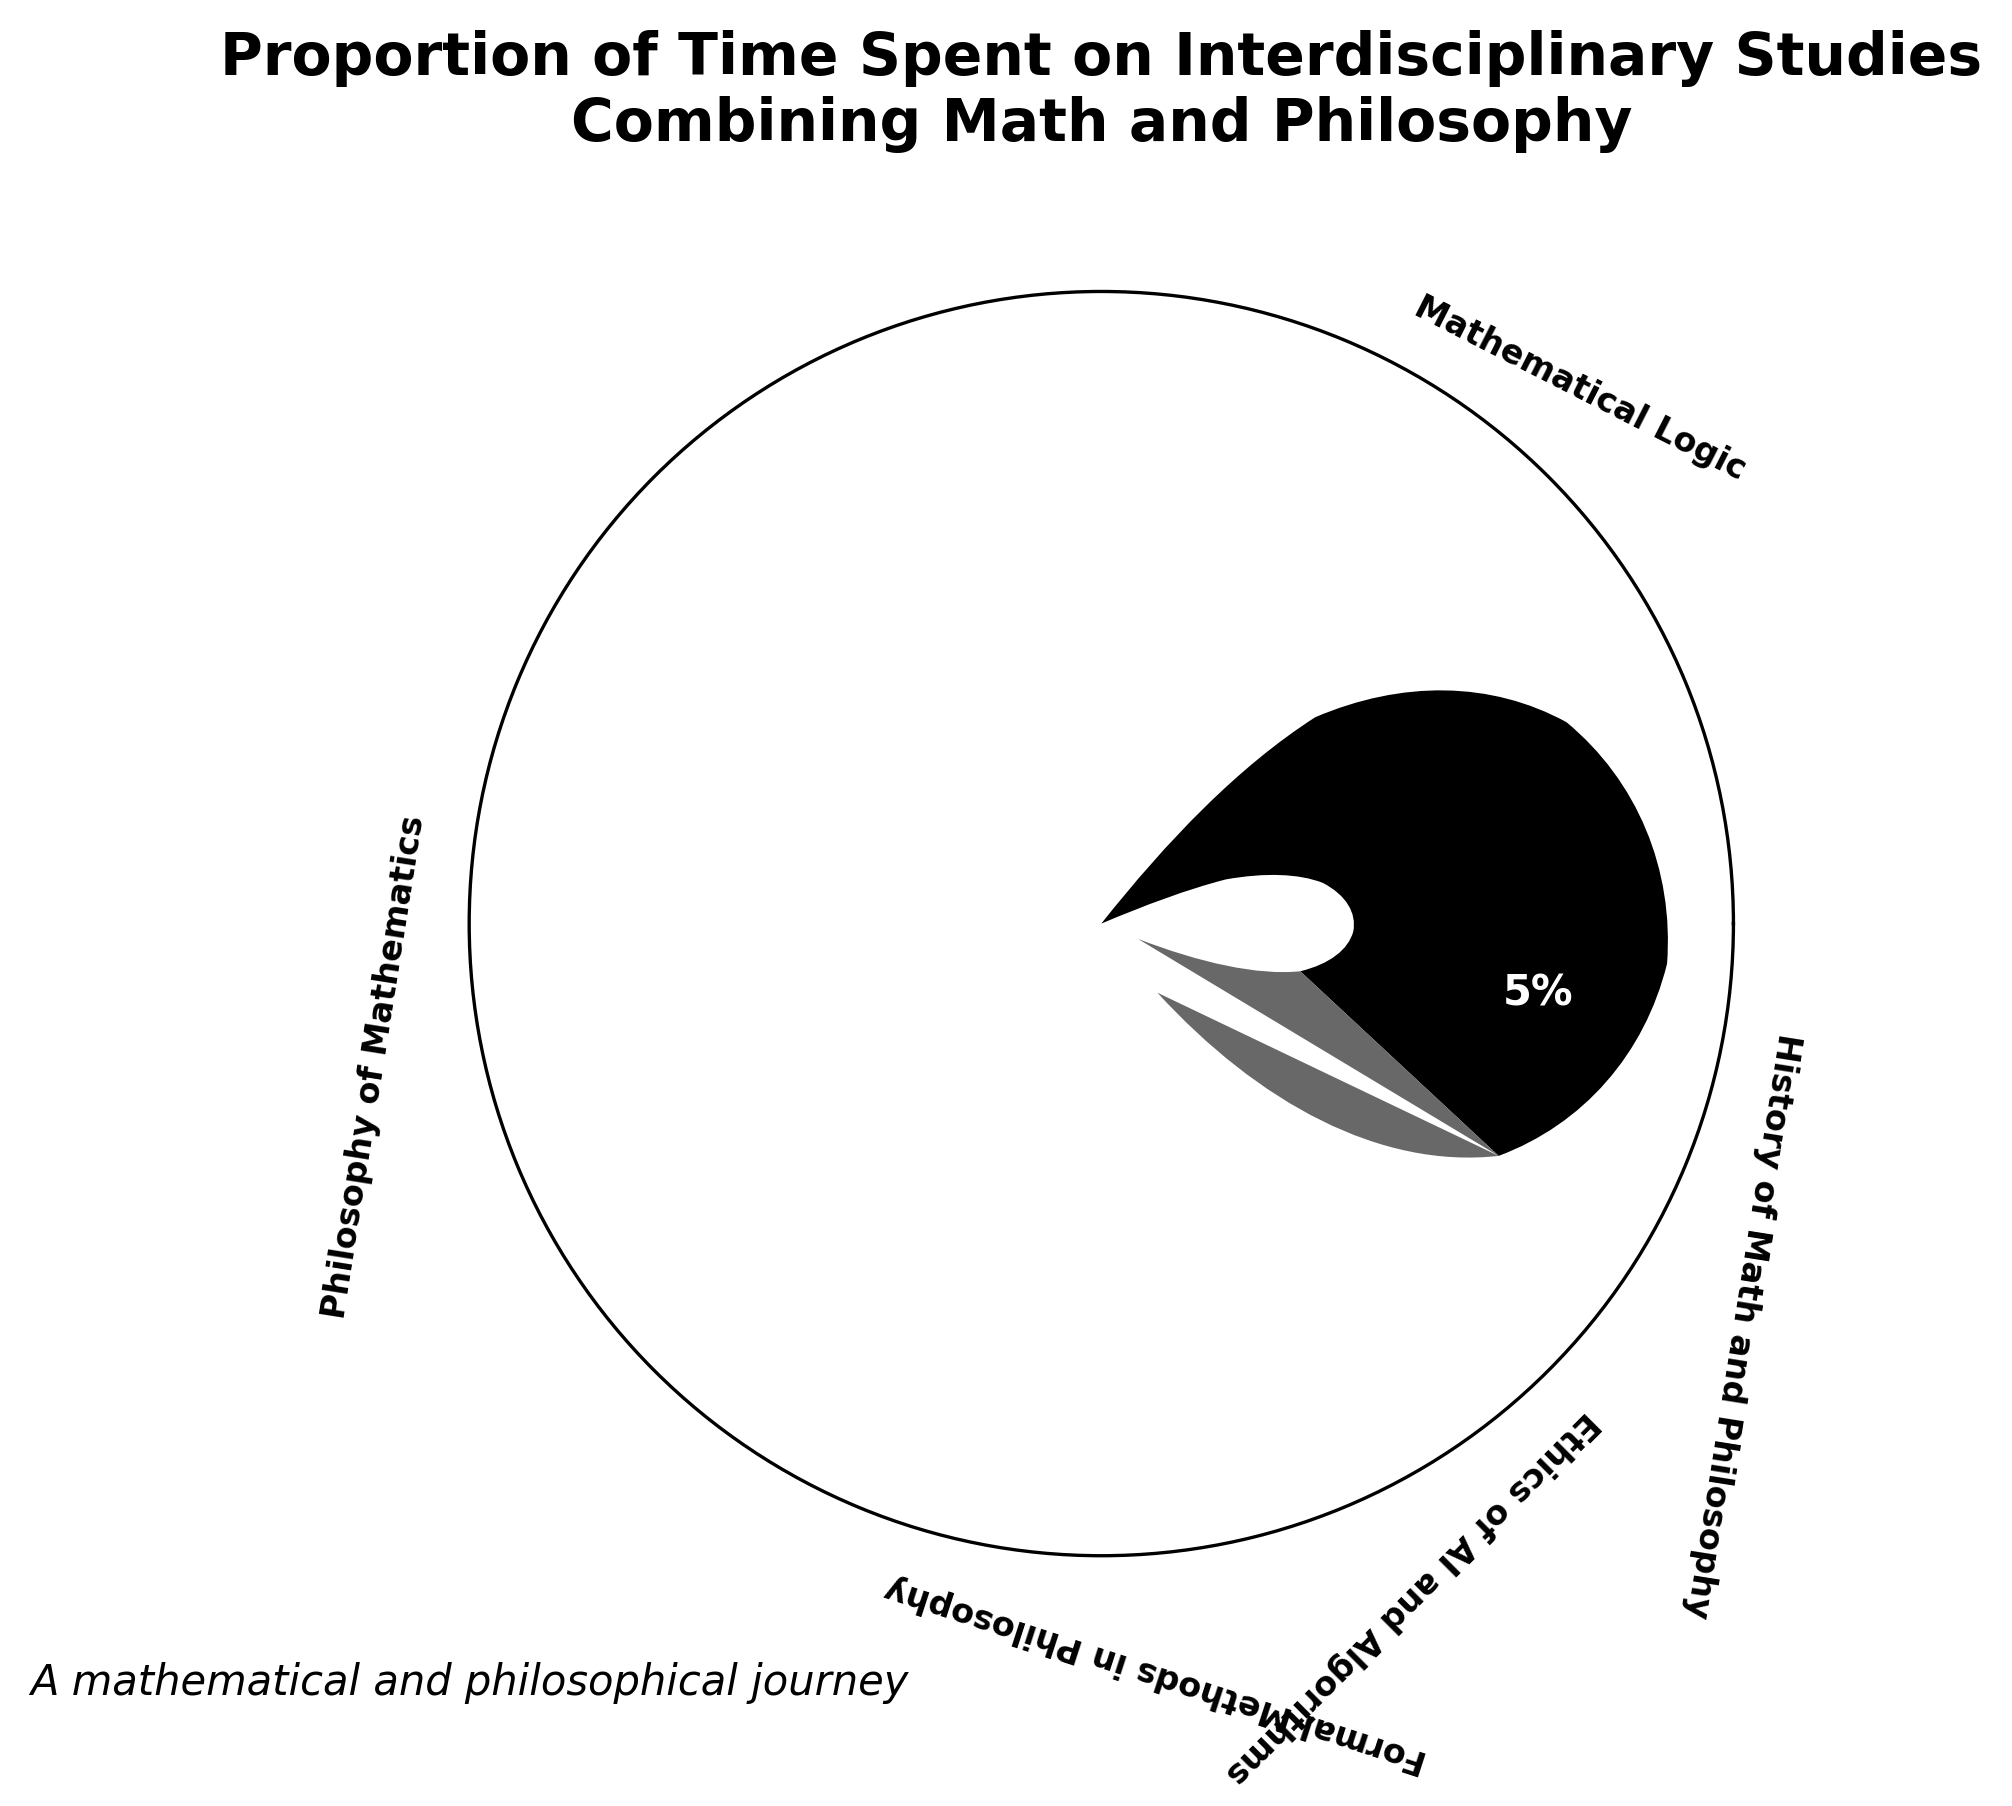what is the title of the plot? The title can be found at the top of the figure. It gives a summary of what the chart is about.
Answer: Proportion of Time Spent on Interdisciplinary Studies Combining Math and Philosophy what category has the highest value? By looking at the wedges and their values, the category with the largest wedge and highest percentage is evident.
Answer: Mathematical Logic how many categories are there in total? The number of distinct segments in the chart represents the number of categories.
Answer: 5 What is the combined proportion for 'Formal Methods in Philosophy' and 'Ethics of AI and Algorithms'? Add the values of the respective categories. Formal Methods in Philosophy: 20% and Ethics of AI and Algorithms: 15%. 20% + 15% = 35%
Answer: 35% Which category has the smallest proportion of time spent? By locating the smallest wedge and observing the percentage, we determine the category.
Answer: History of Math and Philosophy How much more time is spent on 'Mathematical Logic' compared to 'Ethics of AI and Algorithms'? Subtract the percentage of 'Ethics of AI and Algorithms' from 'Mathematical Logic'. 35% - 15% = 20%
Answer: 20% When summing up 'Philosophy of Mathematics', 'Formal Methods in Philosophy', and 'History of Math and Philosophy', what's the total proportion? Add the values of the respective categories: Philosophy of Mathematics (25%), Formal Methods in Philosophy (20%), History of Math and Philosophy (5%). 25% + 20% + 5% = 50%
Answer: 50% How does the proportion of 'Philosophy of Mathematics' compare to 'Formal Methods in Philosophy'? Compare the values directly. Philosophy of Mathematics: 25%, Formal Methods in Philosophy: 20%. 25% is greater than 20%.
Answer: Greater What key visual element is used to represent different categories in the plot? The wedges of varying sizes and shades of gray represent different proportions for each category.
Answer: Wedges What is the average proportion of time spent on each category? Sum the values and divide by the number of categories. (35 + 25 + 20 + 15 + 5) / 5 = 20
Answer: 20% 